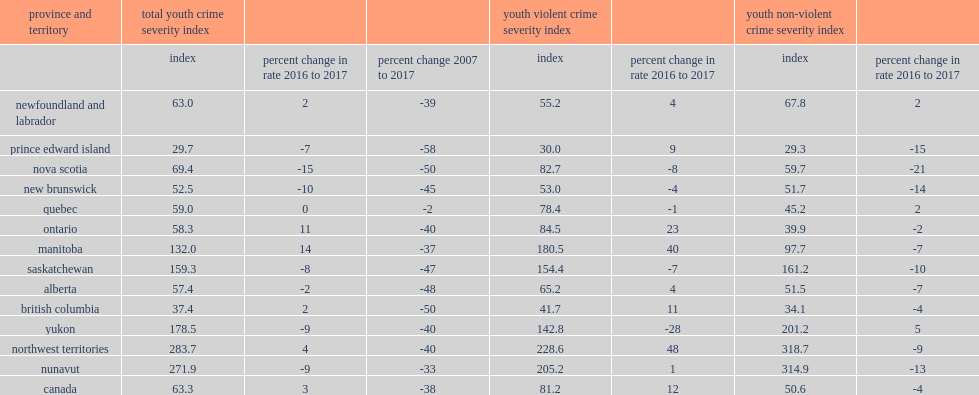List the top3 provinces and territories with the largest increases in ycsi. Manitoba ontario northwest territories. 